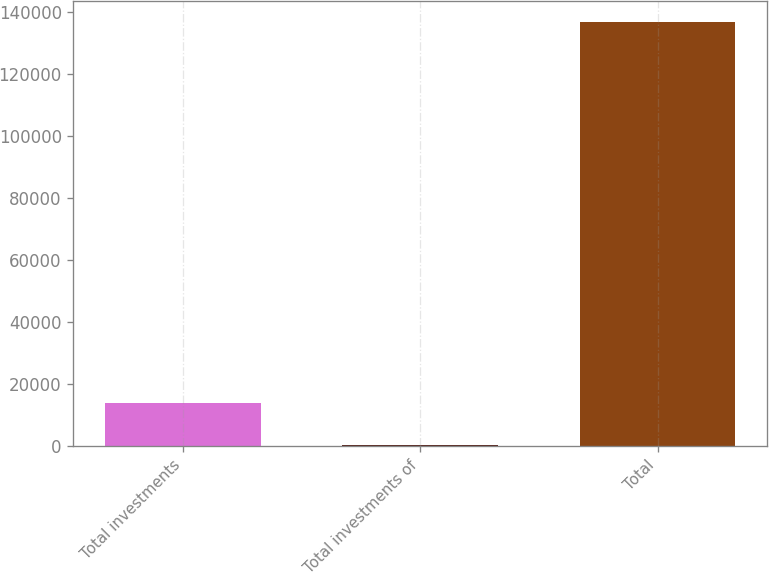<chart> <loc_0><loc_0><loc_500><loc_500><bar_chart><fcel>Total investments<fcel>Total investments of<fcel>Total<nl><fcel>13930<fcel>304<fcel>136564<nl></chart> 